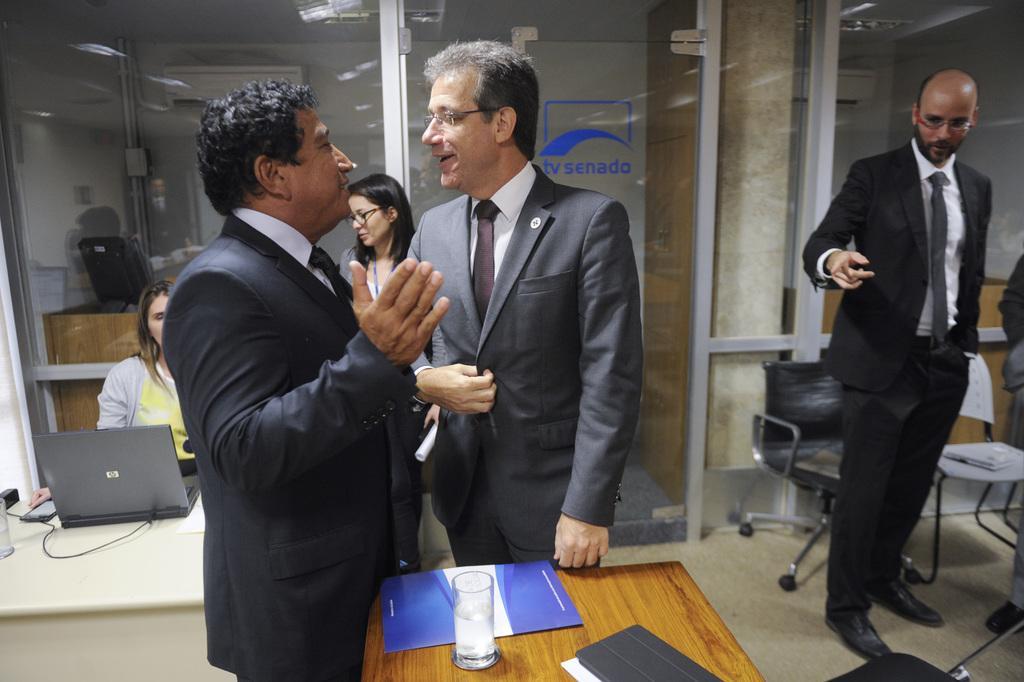In one or two sentences, can you explain what this image depicts? In the image there are few men with suit standing and talking, it seems to be clicked inside office, there is a table in the front and on left side and some chairs over the right side, in the back there is glass wall with two women standing and looking at the laptop on table on the left side. 